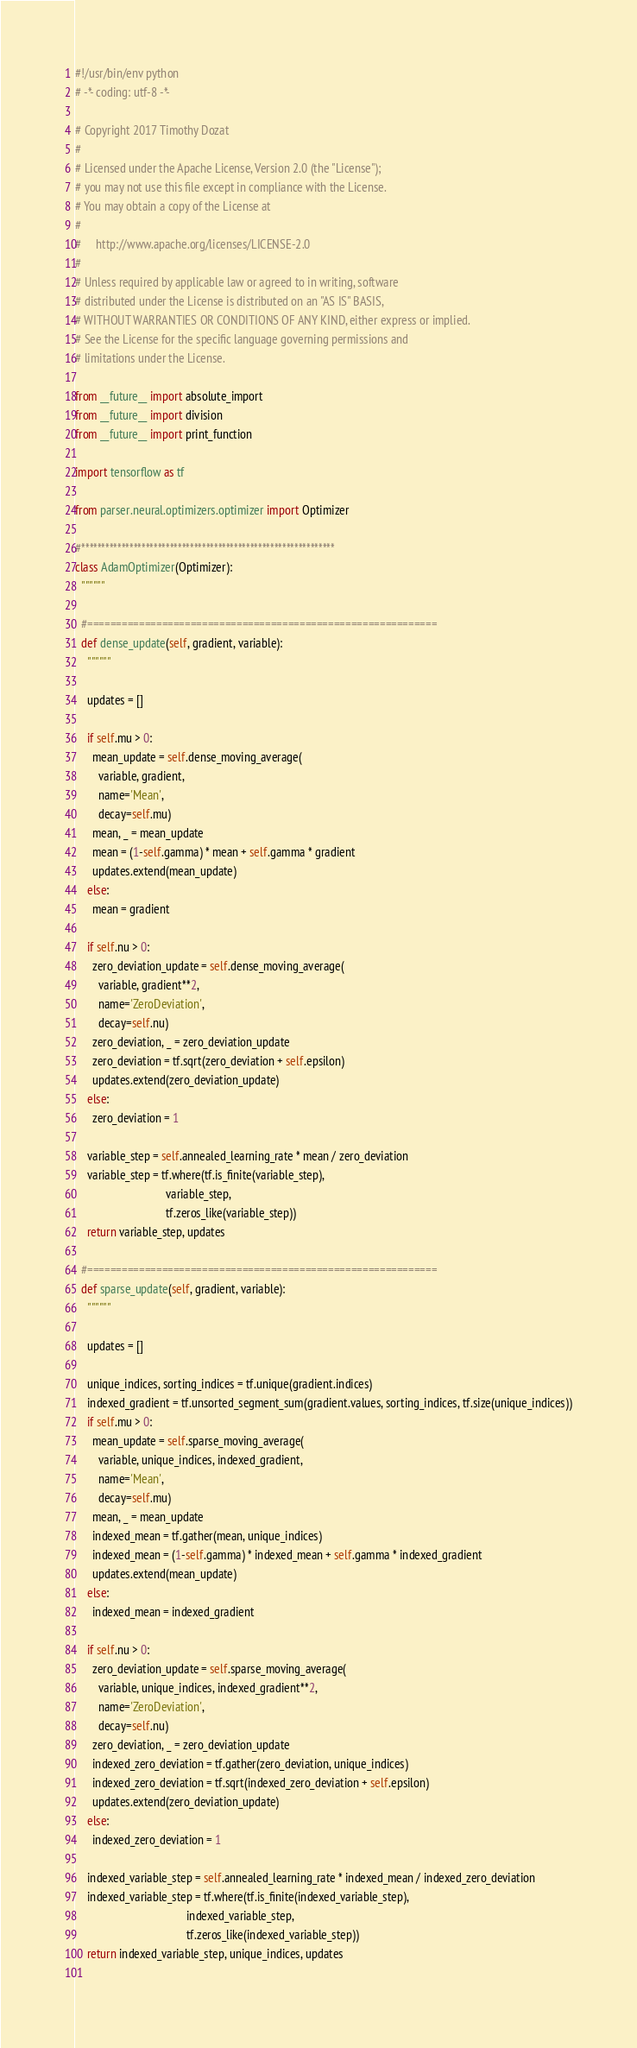Convert code to text. <code><loc_0><loc_0><loc_500><loc_500><_Python_>#!/usr/bin/env python
# -*- coding: utf-8 -*-

# Copyright 2017 Timothy Dozat
# 
# Licensed under the Apache License, Version 2.0 (the "License");
# you may not use this file except in compliance with the License.
# You may obtain a copy of the License at
# 
#     http://www.apache.org/licenses/LICENSE-2.0
# 
# Unless required by applicable law or agreed to in writing, software
# distributed under the License is distributed on an "AS IS" BASIS,
# WITHOUT WARRANTIES OR CONDITIONS OF ANY KIND, either express or implied.
# See the License for the specific language governing permissions and
# limitations under the License.

from __future__ import absolute_import
from __future__ import division
from __future__ import print_function

import tensorflow as tf

from parser.neural.optimizers.optimizer import Optimizer

#***************************************************************
class AdamOptimizer(Optimizer):
  """"""
  
  #=============================================================
  def dense_update(self, gradient, variable):
    """"""
    
    updates = []
    
    if self.mu > 0:
      mean_update = self.dense_moving_average(
        variable, gradient,
        name='Mean',
        decay=self.mu)
      mean, _ = mean_update
      mean = (1-self.gamma) * mean + self.gamma * gradient
      updates.extend(mean_update)
    else:
      mean = gradient
    
    if self.nu > 0:
      zero_deviation_update = self.dense_moving_average(
        variable, gradient**2,
        name='ZeroDeviation',
        decay=self.nu)
      zero_deviation, _ = zero_deviation_update
      zero_deviation = tf.sqrt(zero_deviation + self.epsilon)
      updates.extend(zero_deviation_update)
    else:
      zero_deviation = 1
    
    variable_step = self.annealed_learning_rate * mean / zero_deviation
    variable_step = tf.where(tf.is_finite(variable_step),
                               variable_step,
                               tf.zeros_like(variable_step))
    return variable_step, updates
  
  #=============================================================
  def sparse_update(self, gradient, variable):
    """"""
    
    updates = []
    
    unique_indices, sorting_indices = tf.unique(gradient.indices)
    indexed_gradient = tf.unsorted_segment_sum(gradient.values, sorting_indices, tf.size(unique_indices))
    if self.mu > 0:
      mean_update = self.sparse_moving_average(
        variable, unique_indices, indexed_gradient,
        name='Mean',
        decay=self.mu)
      mean, _ = mean_update
      indexed_mean = tf.gather(mean, unique_indices)
      indexed_mean = (1-self.gamma) * indexed_mean + self.gamma * indexed_gradient
      updates.extend(mean_update)
    else:
      indexed_mean = indexed_gradient
    
    if self.nu > 0:
      zero_deviation_update = self.sparse_moving_average(
        variable, unique_indices, indexed_gradient**2,
        name='ZeroDeviation',
        decay=self.nu)
      zero_deviation, _ = zero_deviation_update
      indexed_zero_deviation = tf.gather(zero_deviation, unique_indices)
      indexed_zero_deviation = tf.sqrt(indexed_zero_deviation + self.epsilon)
      updates.extend(zero_deviation_update)
    else:
      indexed_zero_deviation = 1
    
    indexed_variable_step = self.annealed_learning_rate * indexed_mean / indexed_zero_deviation
    indexed_variable_step = tf.where(tf.is_finite(indexed_variable_step),
                                      indexed_variable_step,
                                      tf.zeros_like(indexed_variable_step))
    return indexed_variable_step, unique_indices, updates
  
</code> 